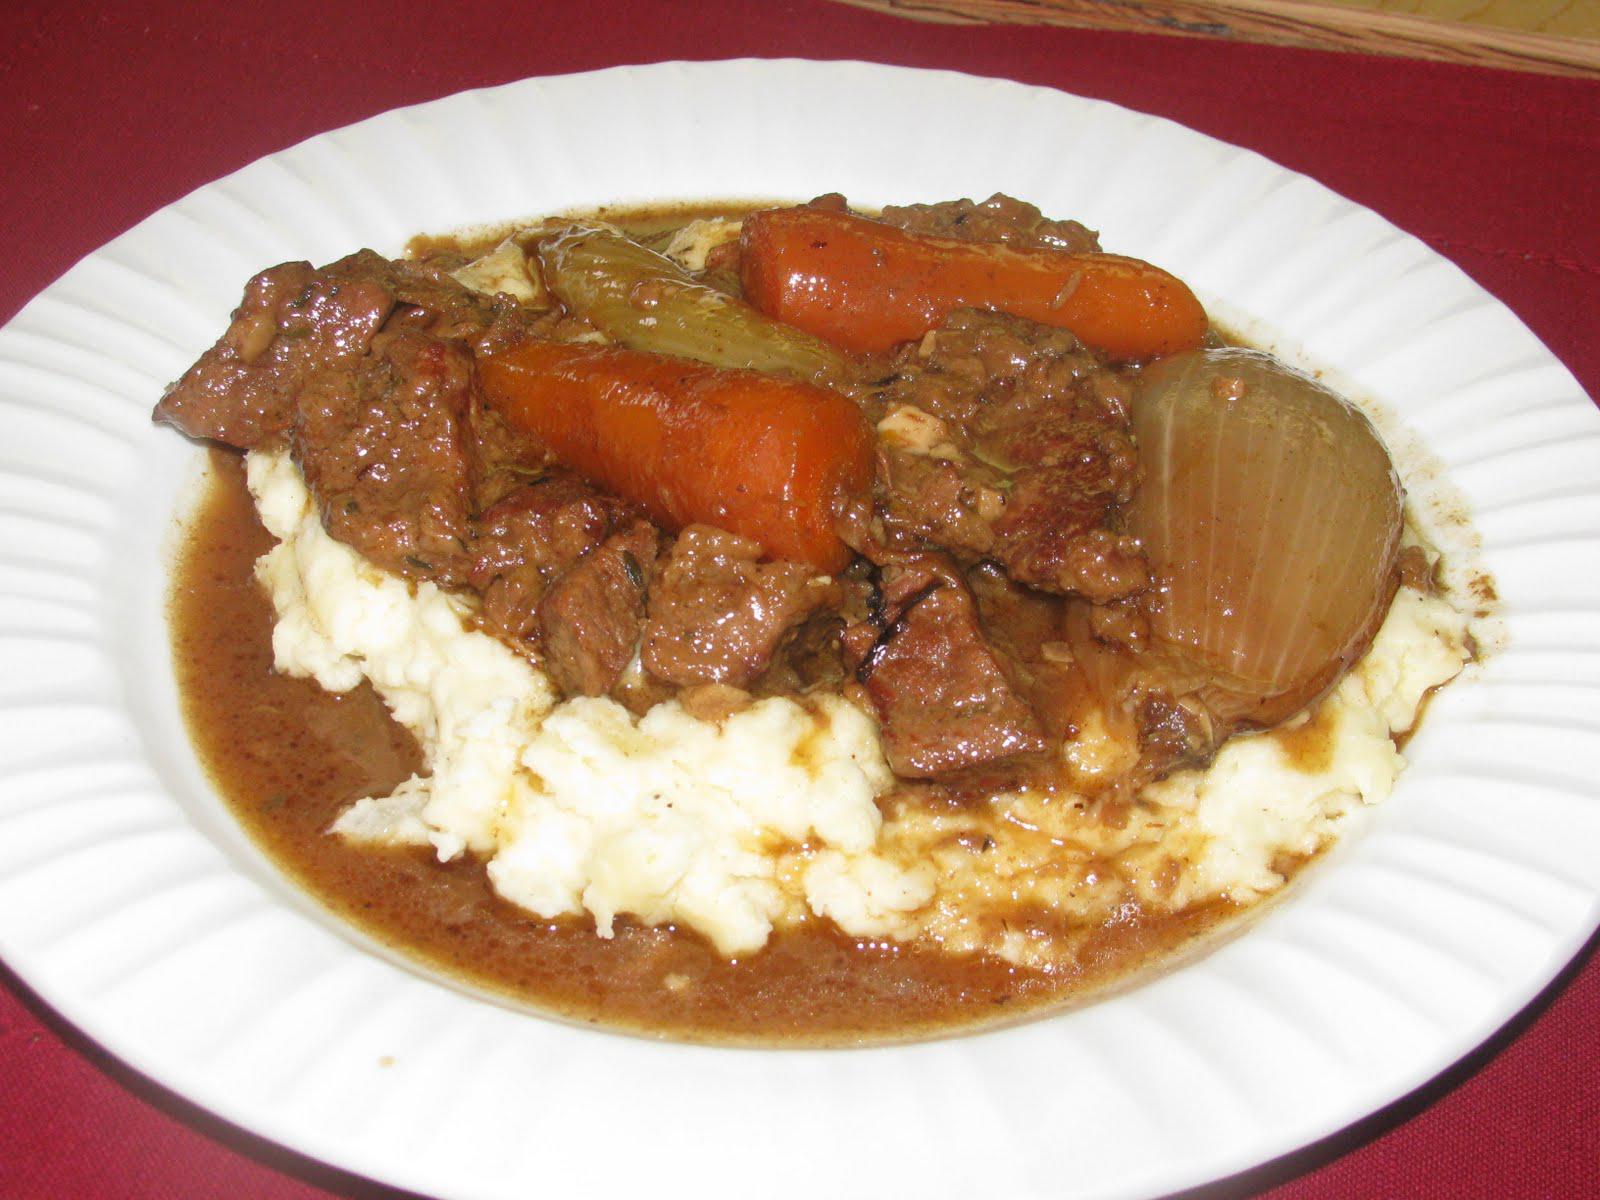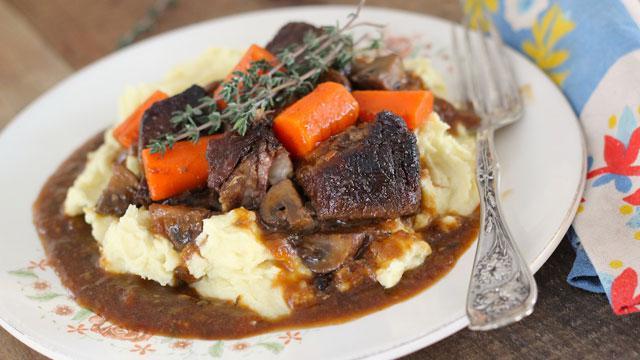The first image is the image on the left, the second image is the image on the right. For the images shown, is this caption "A fork is sitting on the right side of the plate in the image on the right." true? Answer yes or no. Yes. The first image is the image on the left, the second image is the image on the right. Assess this claim about the two images: "A fork is on the edge of a flower-patterned plate containing beef and gravy garnished with green sprigs.". Correct or not? Answer yes or no. Yes. 